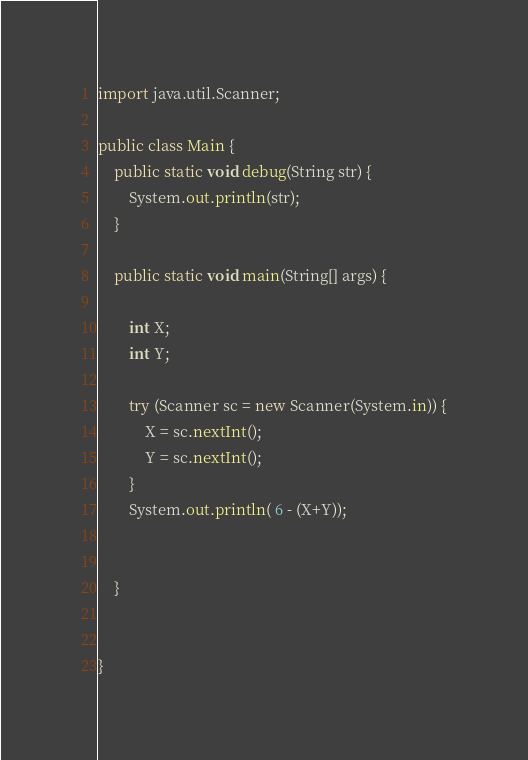<code> <loc_0><loc_0><loc_500><loc_500><_Java_>
import java.util.Scanner;

public class Main {
    public static void debug(String str) {
        System.out.println(str);
    }

    public static void main(String[] args) {

        int X;
        int Y;

        try (Scanner sc = new Scanner(System.in)) {
            X = sc.nextInt();
            Y = sc.nextInt();
        }
        System.out.println( 6 - (X+Y));
        

    }


}
</code> 